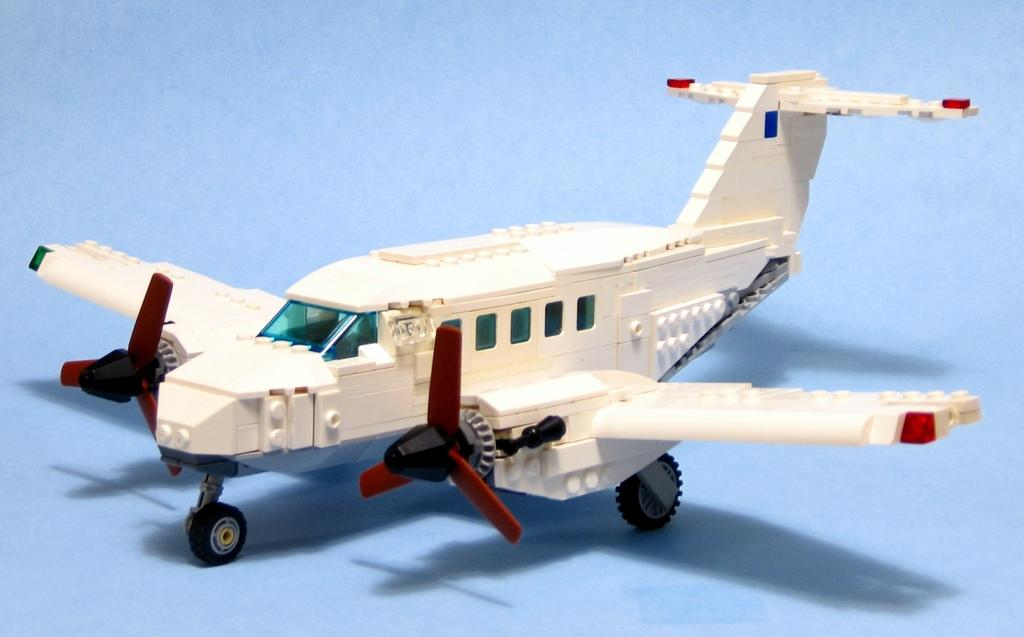What type of toy is in the picture? There is a toy aircraft in the picture. What features does the toy aircraft have? The toy aircraft has propellers and tyres. What background is depicted in the picture? There is a plane background in the picture. What type of clover is growing near the toy aircraft in the picture? There is no clover present in the image; it features a toy aircraft with a plane background. 